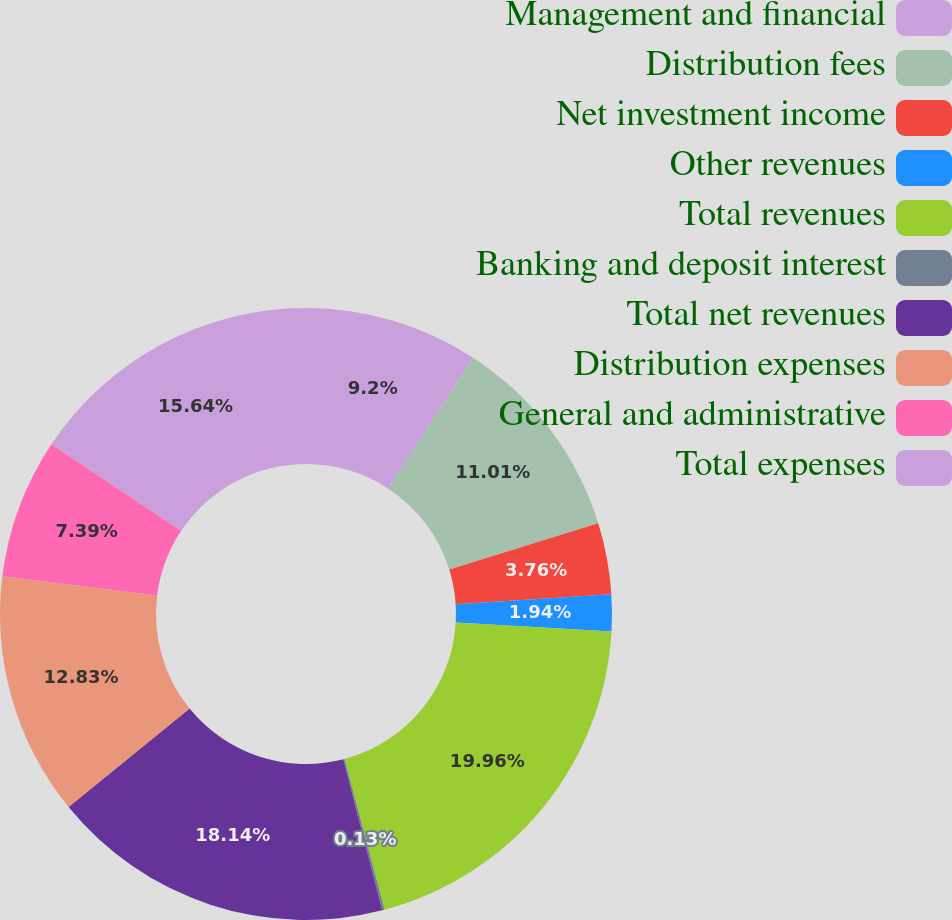<chart> <loc_0><loc_0><loc_500><loc_500><pie_chart><fcel>Management and financial<fcel>Distribution fees<fcel>Net investment income<fcel>Other revenues<fcel>Total revenues<fcel>Banking and deposit interest<fcel>Total net revenues<fcel>Distribution expenses<fcel>General and administrative<fcel>Total expenses<nl><fcel>9.2%<fcel>11.01%<fcel>3.76%<fcel>1.94%<fcel>19.95%<fcel>0.13%<fcel>18.14%<fcel>12.83%<fcel>7.39%<fcel>15.64%<nl></chart> 